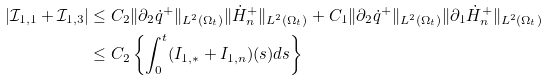Convert formula to latex. <formula><loc_0><loc_0><loc_500><loc_500>| \mathcal { I } _ { 1 , 1 } + \mathcal { I } _ { 1 , 3 } | & \leq C _ { 2 } \| \partial _ { 2 } \dot { q } ^ { + } \| _ { L ^ { 2 } ( \Omega _ { t } ) } \| \dot { H } ^ { + } _ { n } \| _ { L ^ { 2 } ( \Omega _ { t } ) } + C _ { 1 } \| \partial _ { 2 } \dot { q } ^ { + } \| _ { L ^ { 2 } ( \Omega _ { t } ) } \| \partial _ { 1 } \dot { H } ^ { + } _ { n } \| _ { L ^ { 2 } ( \Omega _ { t } ) } \\ & \leq C _ { 2 } \left \{ \int _ { 0 } ^ { t } ( I _ { 1 , \ast } + I _ { 1 , n } ) ( s ) d s \right \}</formula> 